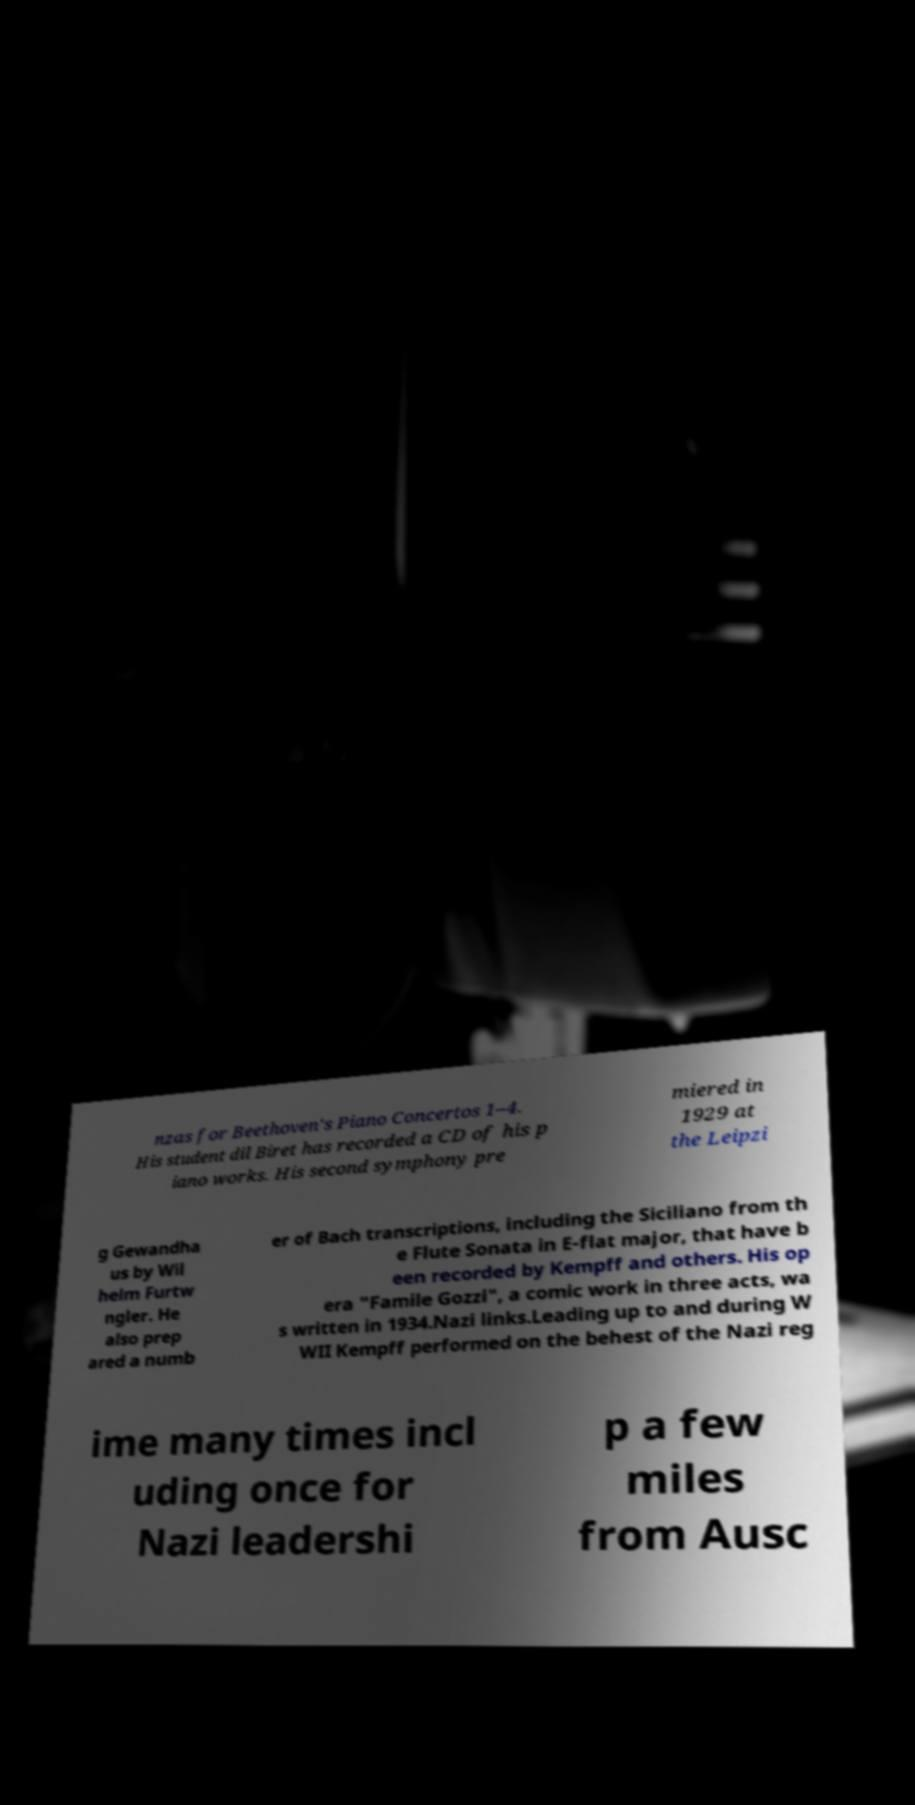Can you read and provide the text displayed in the image?This photo seems to have some interesting text. Can you extract and type it out for me? nzas for Beethoven's Piano Concertos 1–4. His student dil Biret has recorded a CD of his p iano works. His second symphony pre miered in 1929 at the Leipzi g Gewandha us by Wil helm Furtw ngler. He also prep ared a numb er of Bach transcriptions, including the Siciliano from th e Flute Sonata in E-flat major, that have b een recorded by Kempff and others. His op era "Famile Gozzi", a comic work in three acts, wa s written in 1934.Nazi links.Leading up to and during W WII Kempff performed on the behest of the Nazi reg ime many times incl uding once for Nazi leadershi p a few miles from Ausc 